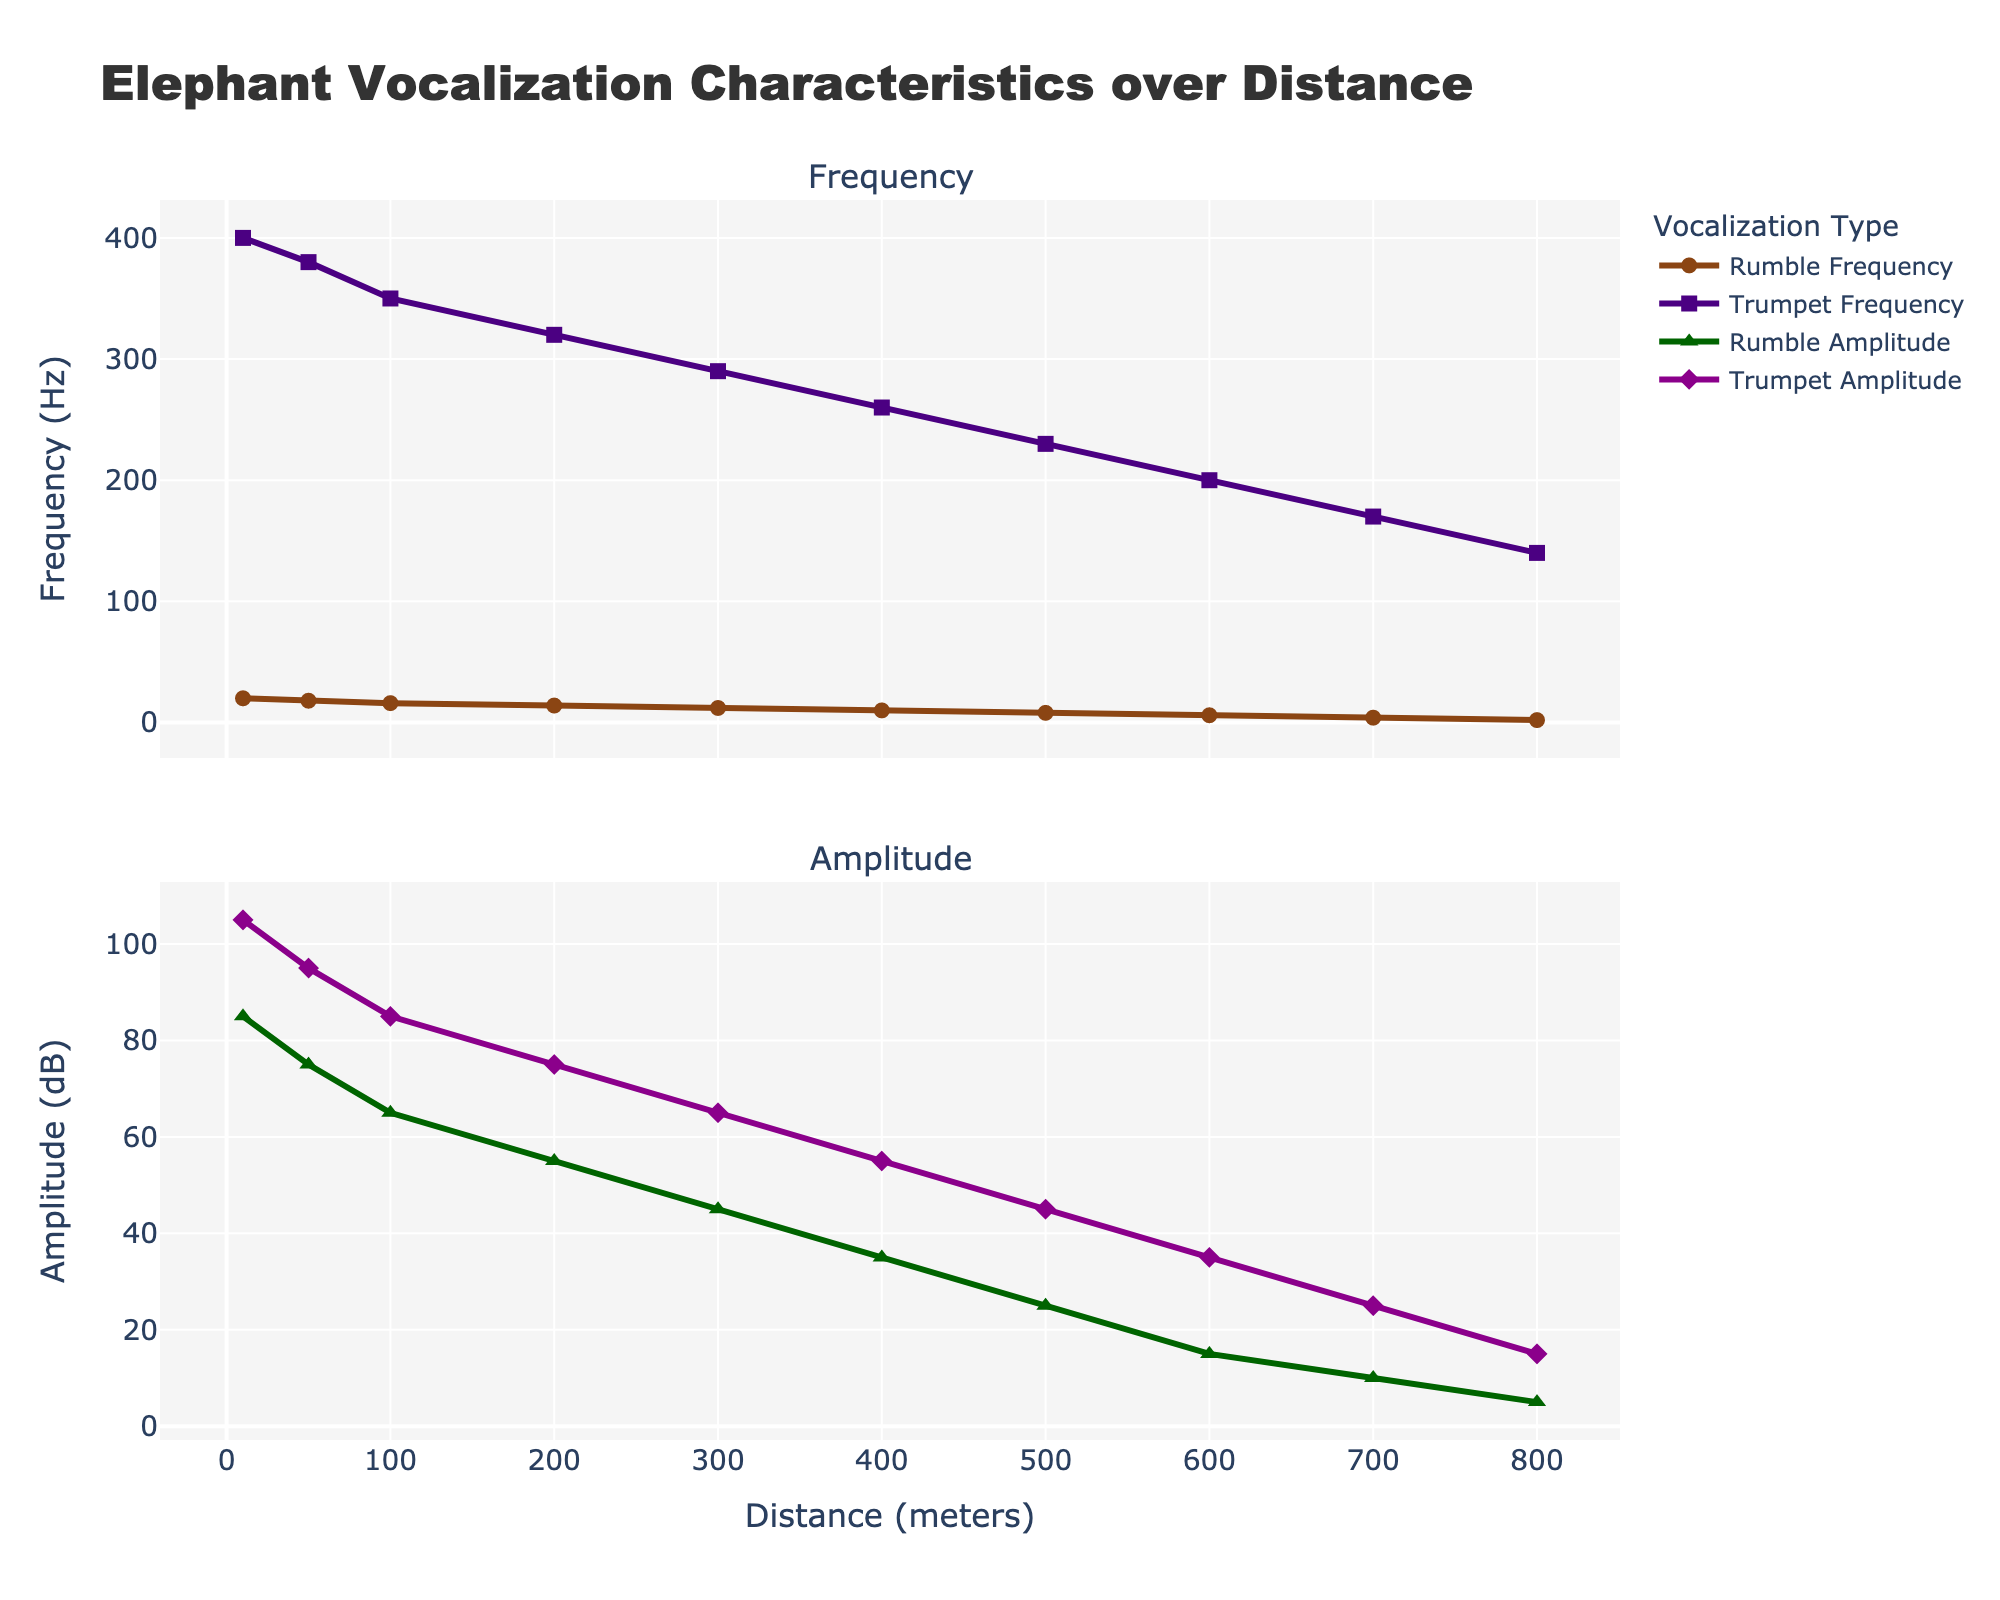What's the general trend in Rumble Frequency as distance increases? The plot shows that Rumble Frequency steadily decreases from 20 Hz at 10 meters to 2 Hz at 800 meters
Answer: It decreases Compare the amplitude of Rumble and Trumpet vocalizations at 300 meters. The plot indicates that Rumble Amplitude at 300 meters is 45 dB, and Trumpet Amplitude is 65 dB; hence, Trumpet Amplitude is higher.
Answer: Trumpet Amplitude is higher At what distance does the Rumble Amplitude drop below 50 dB? The plot of Rumble Amplitude shows multiple values, and the first point where it drops below 50 dB is at 200 meters
Answer: 200 meters Which vocalization type has a higher amplitude at 500 meters, and by how much? At 500 meters, the Rumble Amplitude is 25 dB, and the Trumpet Amplitude is 45 dB, so Trumpet Amplitude is higher by 45 - 25 = 20 dB
Answer: Trumpet Amplitude by 20 dB What's the average Rumble Amplitude at 10 and 200 meters? To find the average, add Rumble Amplitudes at 10 and 200 meters: (85 + 55) = 140, then divide by 2, 140/2 = 70 dB
Answer: 70 dB Which type of vocalization decreases more rapidly in frequency as the distance increases? Comparing the slopes of the lines for Rumble and Trumpet Frequencies, Rumble Frequency drops from 20 Hz to 2 Hz more sharply than Trumpet Frequency, which drops from 400 Hz to 140 Hz
Answer: Rumble Frequency Calculate the mean amplitude of Trumpet vocalizations. To find the mean, sum all Trumpet Amplitude values: (105 + 95 + 85 + 75 + 65 + 55 + 45 + 35 + 25 + 15) = 600, then divide by number of data points: 600/10 = 60 dB
Answer: 60 dB Compare the amplitude of Rumble and Trumpet at their highest values. Which one is higher? The highest amplitude for Rumble is 85 dB, and for Trumpet is 105 dB; thus, Trumpet Amplitude is higher
Answer: Trumpet Amplitude is higher At what distance do the frequencies of Rumble and Trumpet vocalizations differ the most? The difference is computed for each distance: (400-20), (380-18), (350-16), etc., the largest difference is at 10 meters, which is 400 - 20 = 380 Hz
Answer: 10 meters 